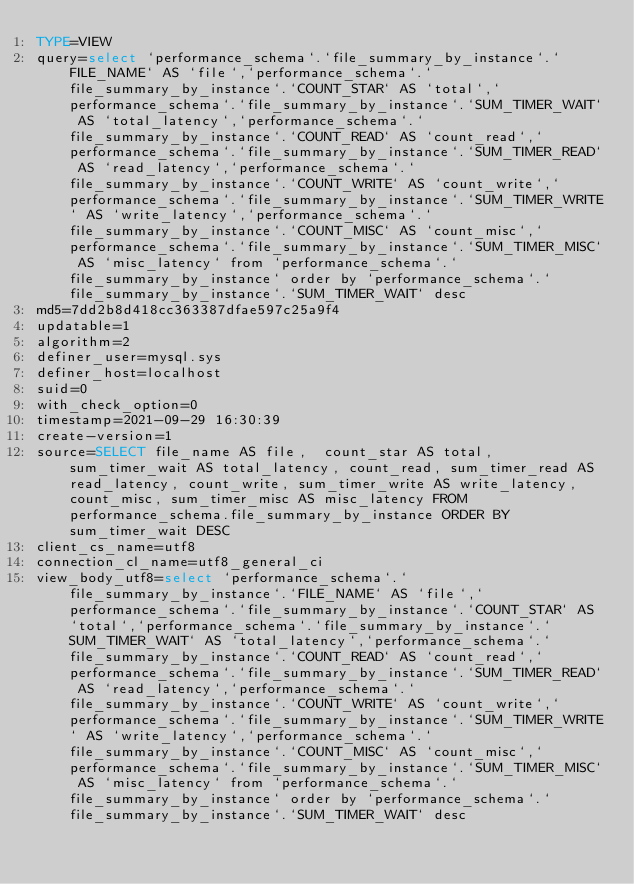Convert code to text. <code><loc_0><loc_0><loc_500><loc_500><_VisualBasic_>TYPE=VIEW
query=select `performance_schema`.`file_summary_by_instance`.`FILE_NAME` AS `file`,`performance_schema`.`file_summary_by_instance`.`COUNT_STAR` AS `total`,`performance_schema`.`file_summary_by_instance`.`SUM_TIMER_WAIT` AS `total_latency`,`performance_schema`.`file_summary_by_instance`.`COUNT_READ` AS `count_read`,`performance_schema`.`file_summary_by_instance`.`SUM_TIMER_READ` AS `read_latency`,`performance_schema`.`file_summary_by_instance`.`COUNT_WRITE` AS `count_write`,`performance_schema`.`file_summary_by_instance`.`SUM_TIMER_WRITE` AS `write_latency`,`performance_schema`.`file_summary_by_instance`.`COUNT_MISC` AS `count_misc`,`performance_schema`.`file_summary_by_instance`.`SUM_TIMER_MISC` AS `misc_latency` from `performance_schema`.`file_summary_by_instance` order by `performance_schema`.`file_summary_by_instance`.`SUM_TIMER_WAIT` desc
md5=7dd2b8d418cc363387dfae597c25a9f4
updatable=1
algorithm=2
definer_user=mysql.sys
definer_host=localhost
suid=0
with_check_option=0
timestamp=2021-09-29 16:30:39
create-version=1
source=SELECT file_name AS file,  count_star AS total,  sum_timer_wait AS total_latency, count_read, sum_timer_read AS read_latency, count_write, sum_timer_write AS write_latency, count_misc, sum_timer_misc AS misc_latency FROM performance_schema.file_summary_by_instance ORDER BY sum_timer_wait DESC
client_cs_name=utf8
connection_cl_name=utf8_general_ci
view_body_utf8=select `performance_schema`.`file_summary_by_instance`.`FILE_NAME` AS `file`,`performance_schema`.`file_summary_by_instance`.`COUNT_STAR` AS `total`,`performance_schema`.`file_summary_by_instance`.`SUM_TIMER_WAIT` AS `total_latency`,`performance_schema`.`file_summary_by_instance`.`COUNT_READ` AS `count_read`,`performance_schema`.`file_summary_by_instance`.`SUM_TIMER_READ` AS `read_latency`,`performance_schema`.`file_summary_by_instance`.`COUNT_WRITE` AS `count_write`,`performance_schema`.`file_summary_by_instance`.`SUM_TIMER_WRITE` AS `write_latency`,`performance_schema`.`file_summary_by_instance`.`COUNT_MISC` AS `count_misc`,`performance_schema`.`file_summary_by_instance`.`SUM_TIMER_MISC` AS `misc_latency` from `performance_schema`.`file_summary_by_instance` order by `performance_schema`.`file_summary_by_instance`.`SUM_TIMER_WAIT` desc
</code> 